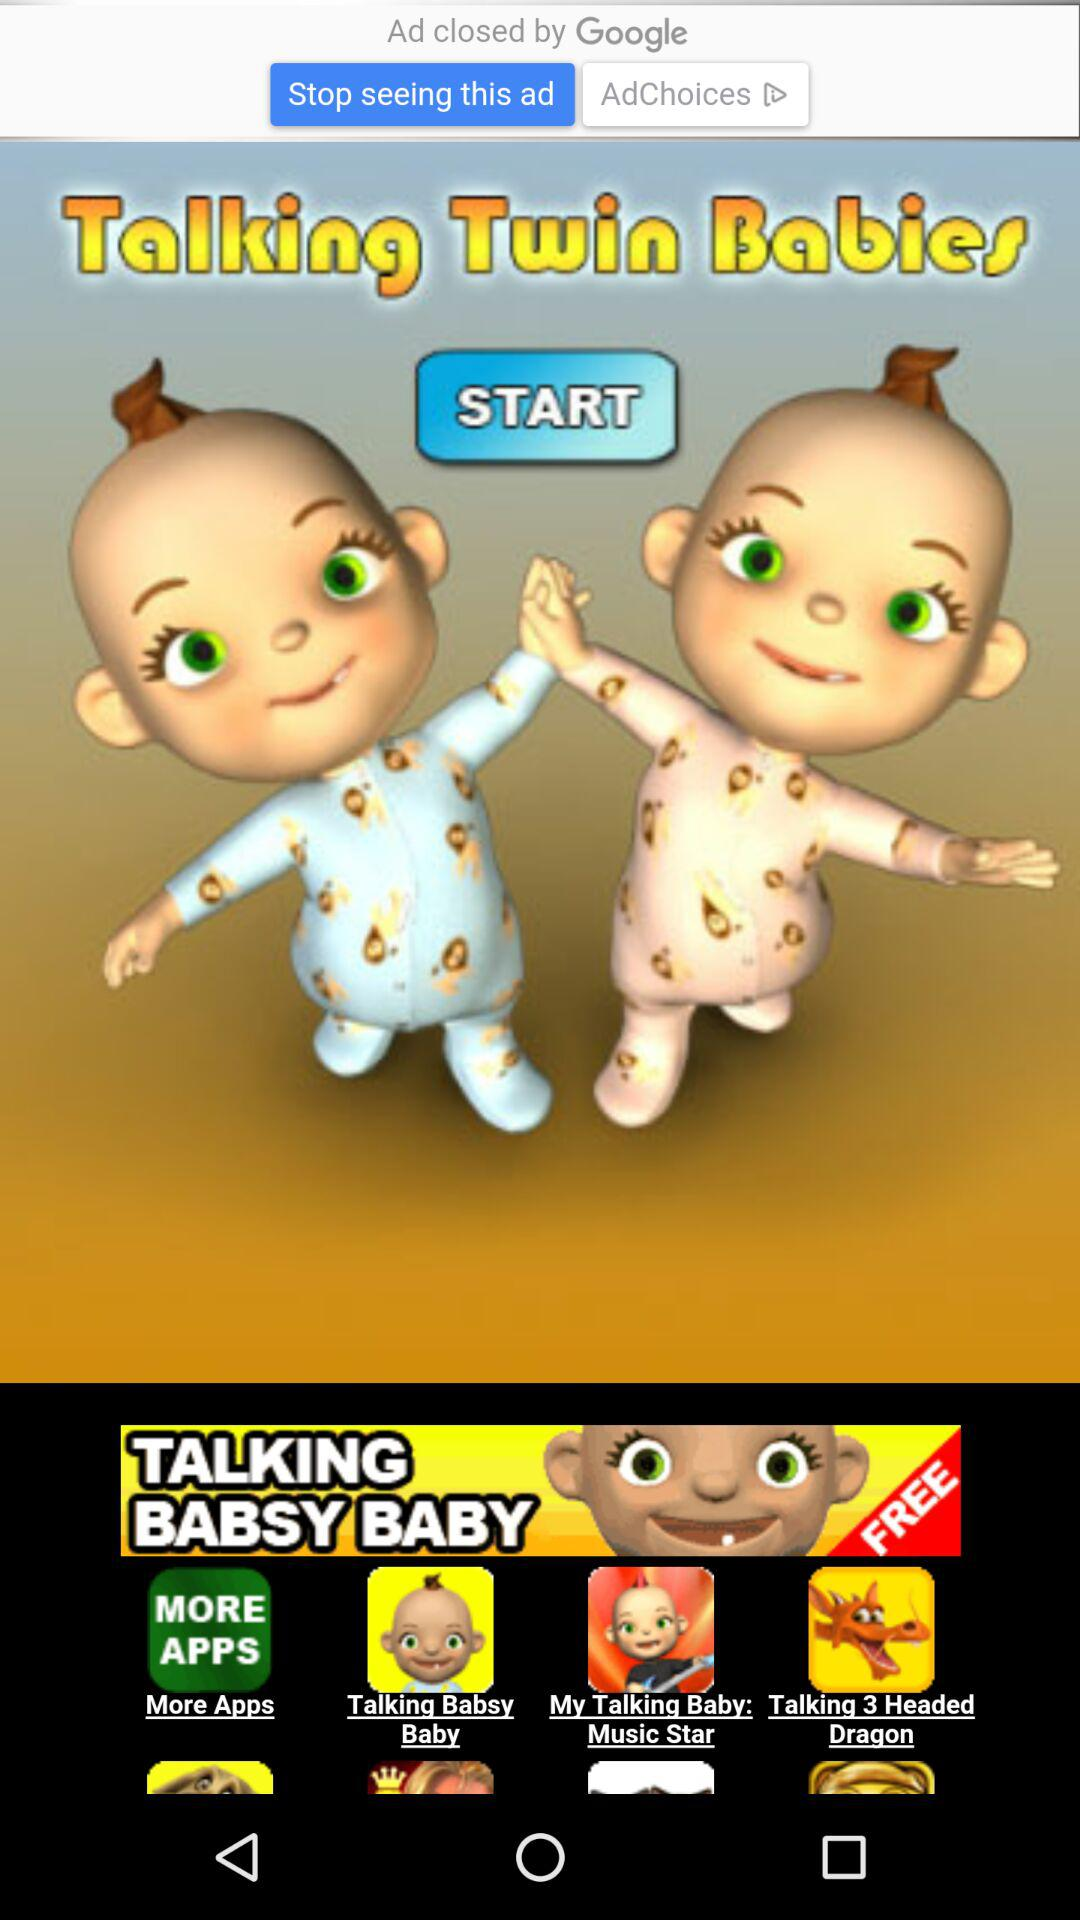What is the application name? The application name is "Talking Twin Babies". 